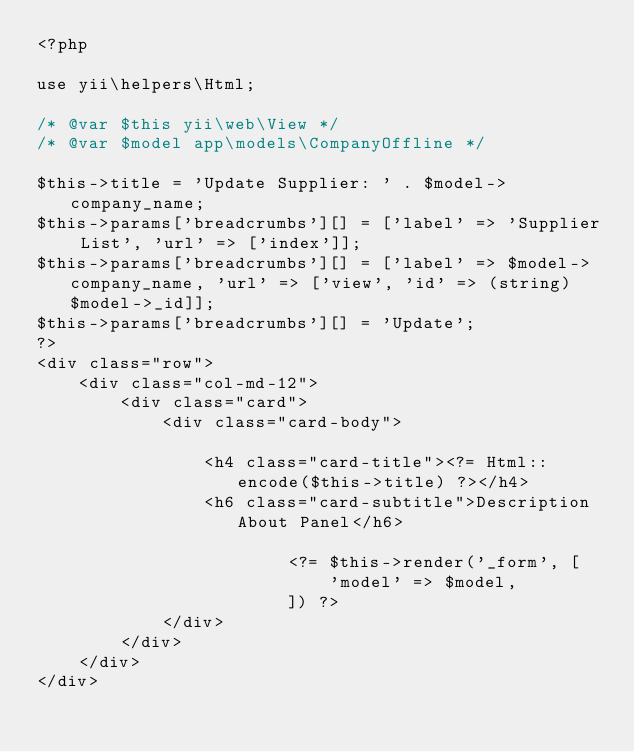<code> <loc_0><loc_0><loc_500><loc_500><_PHP_><?php

use yii\helpers\Html;

/* @var $this yii\web\View */
/* @var $model app\models\CompanyOffline */

$this->title = 'Update Supplier: ' . $model->company_name;
$this->params['breadcrumbs'][] = ['label' => 'Supplier List', 'url' => ['index']];
$this->params['breadcrumbs'][] = ['label' => $model->company_name, 'url' => ['view', 'id' => (string)$model->_id]];
$this->params['breadcrumbs'][] = 'Update';
?>
<div class="row">
    <div class="col-md-12">
        <div class="card">
            <div class="card-body">

                <h4 class="card-title"><?= Html::encode($this->title) ?></h4>
                <h6 class="card-subtitle">Description About Panel</h6>

					    <?= $this->render('_form', [
					        'model' => $model,
					    ]) ?>
			</div>
		</div>
	</div>
</div>
</code> 